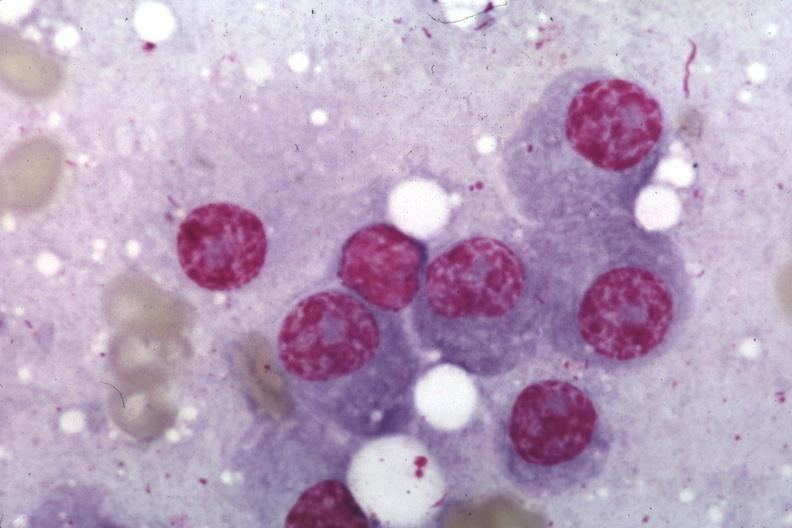does this image show wrights typical plasma cells?
Answer the question using a single word or phrase. Yes 